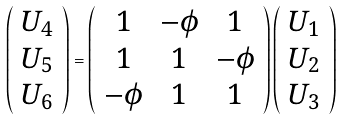<formula> <loc_0><loc_0><loc_500><loc_500>\left ( \begin{array} { c } U _ { 4 } \\ U _ { 5 } \\ U _ { 6 } \end{array} \right ) = \left ( \begin{array} { c c c } 1 & - \phi & 1 \\ 1 & 1 & - \phi \\ - \phi & 1 & 1 \end{array} \right ) \left ( \begin{array} { c } U _ { 1 } \\ U _ { 2 } \\ U _ { 3 } \end{array} \right )</formula> 